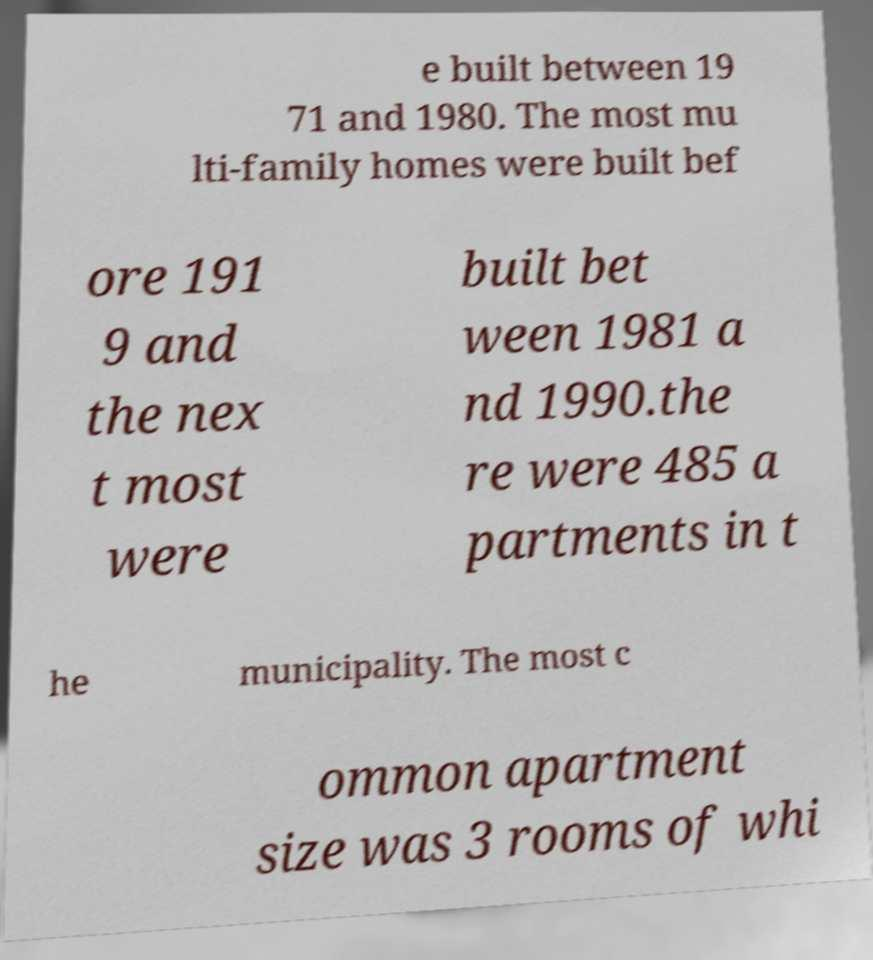For documentation purposes, I need the text within this image transcribed. Could you provide that? e built between 19 71 and 1980. The most mu lti-family homes were built bef ore 191 9 and the nex t most were built bet ween 1981 a nd 1990.the re were 485 a partments in t he municipality. The most c ommon apartment size was 3 rooms of whi 